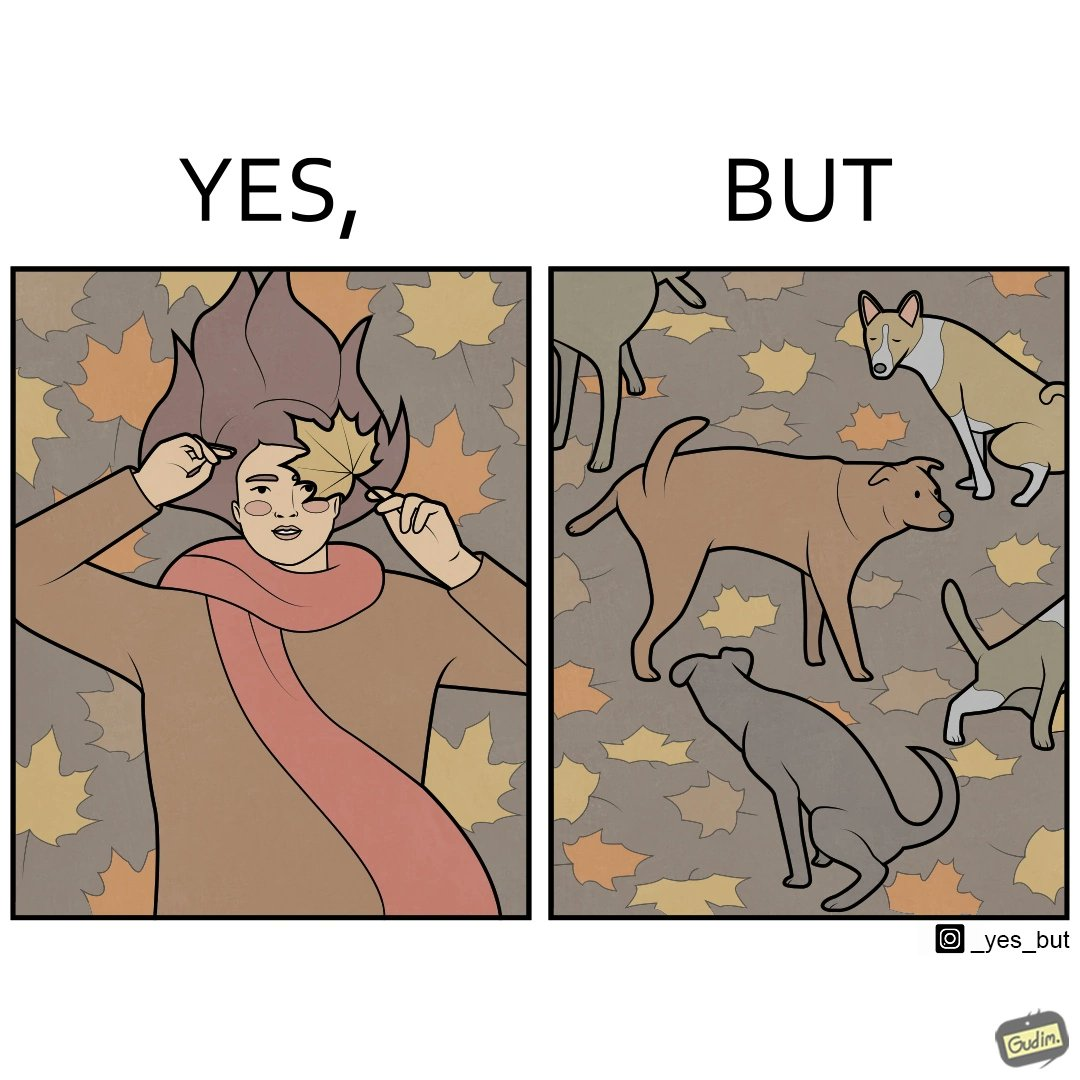Describe the satirical element in this image. The images are funny since it show a woman holding a leaf over half of her face for a good photo but unknown to her is thale fact the same leaf might have been defecated or urinated upon by dogs and other wild animals 